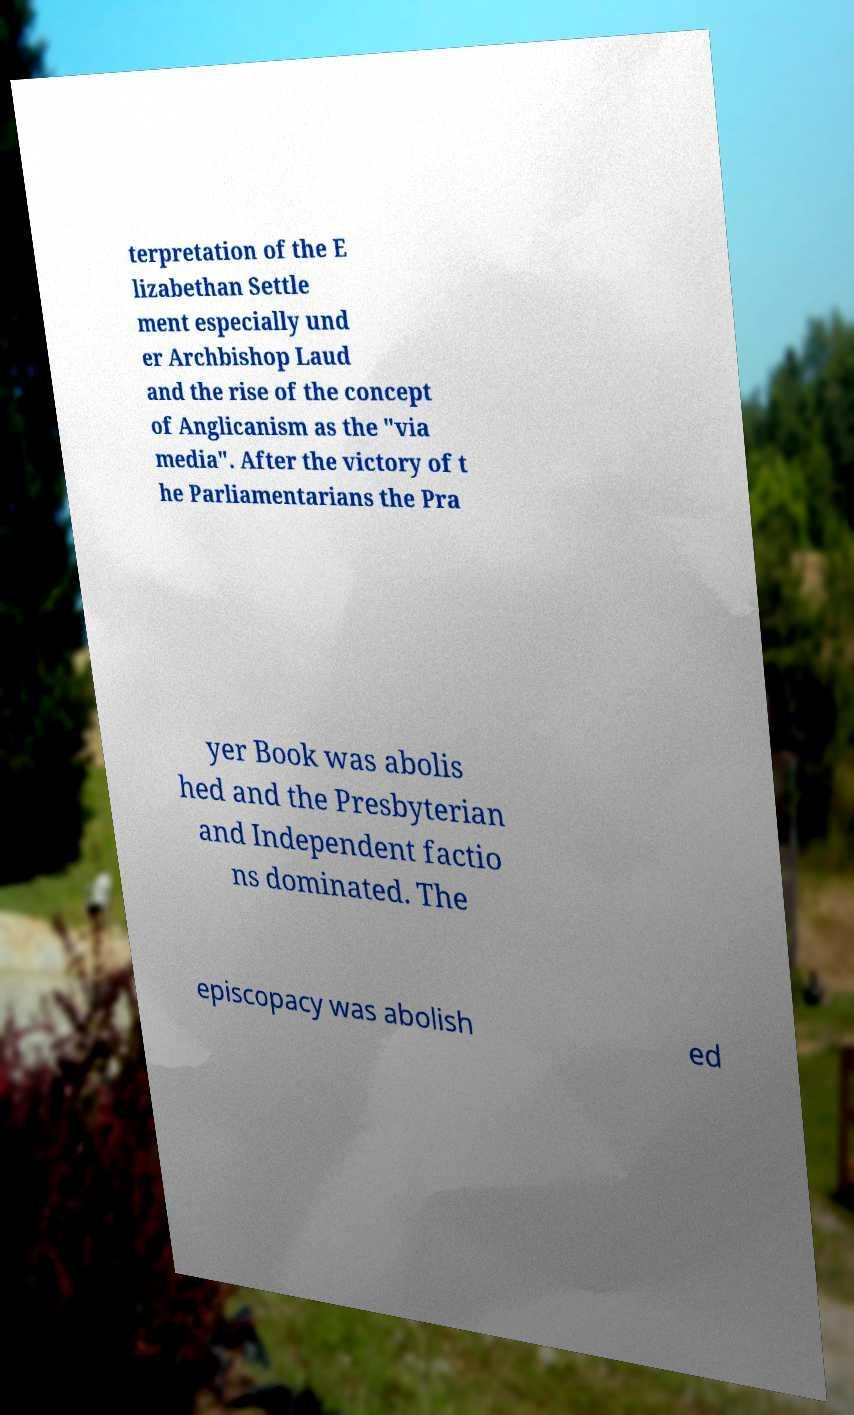Can you read and provide the text displayed in the image?This photo seems to have some interesting text. Can you extract and type it out for me? terpretation of the E lizabethan Settle ment especially und er Archbishop Laud and the rise of the concept of Anglicanism as the "via media". After the victory of t he Parliamentarians the Pra yer Book was abolis hed and the Presbyterian and Independent factio ns dominated. The episcopacy was abolish ed 